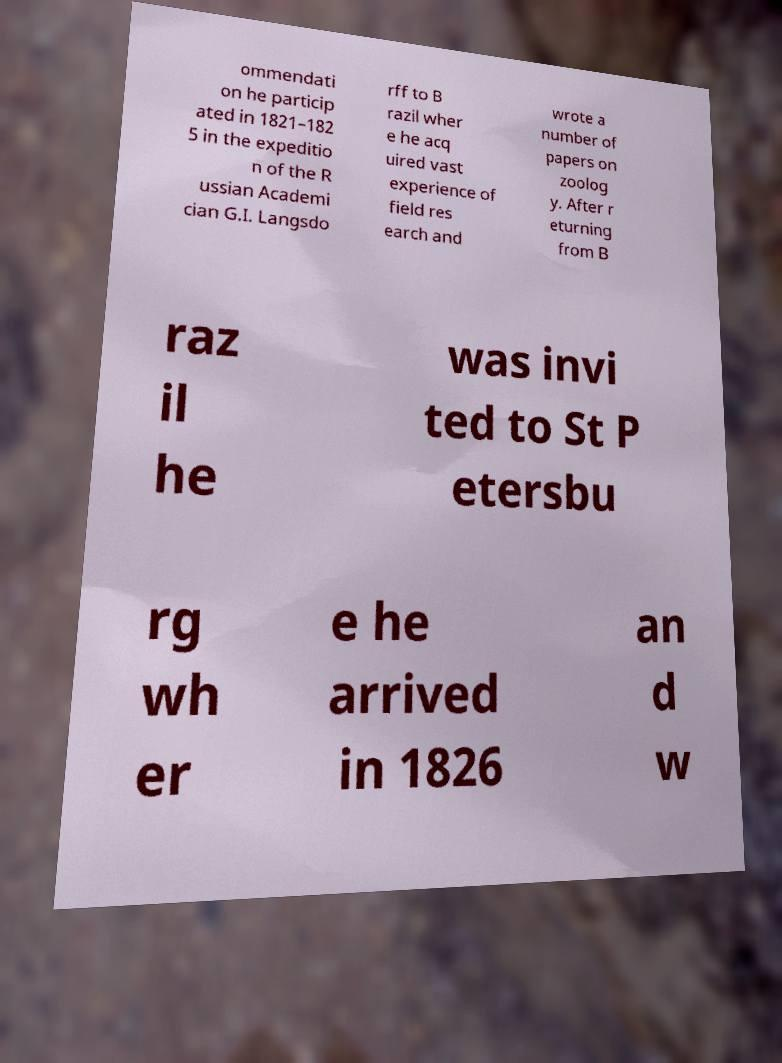Please identify and transcribe the text found in this image. ommendati on he particip ated in 1821–182 5 in the expeditio n of the R ussian Academi cian G.I. Langsdo rff to B razil wher e he acq uired vast experience of field res earch and wrote a number of papers on zoolog y. After r eturning from B raz il he was invi ted to St P etersbu rg wh er e he arrived in 1826 an d w 